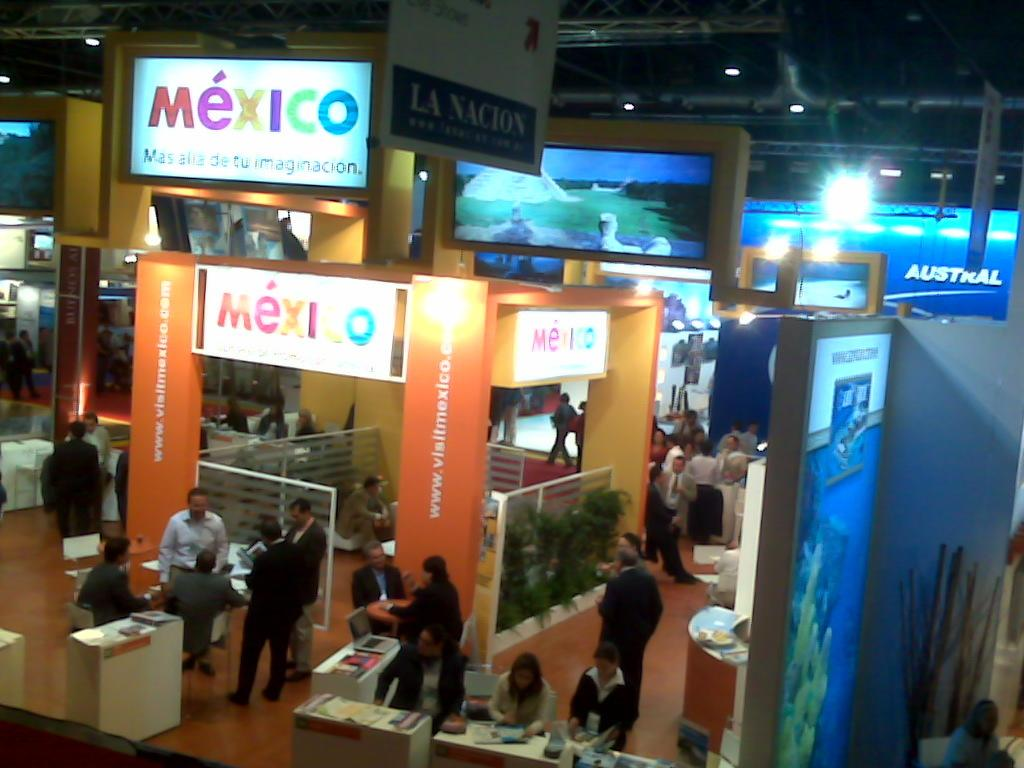Provide a one-sentence caption for the provided image. A store with the word Mexico hanging from the ceiling in different colored letters. 